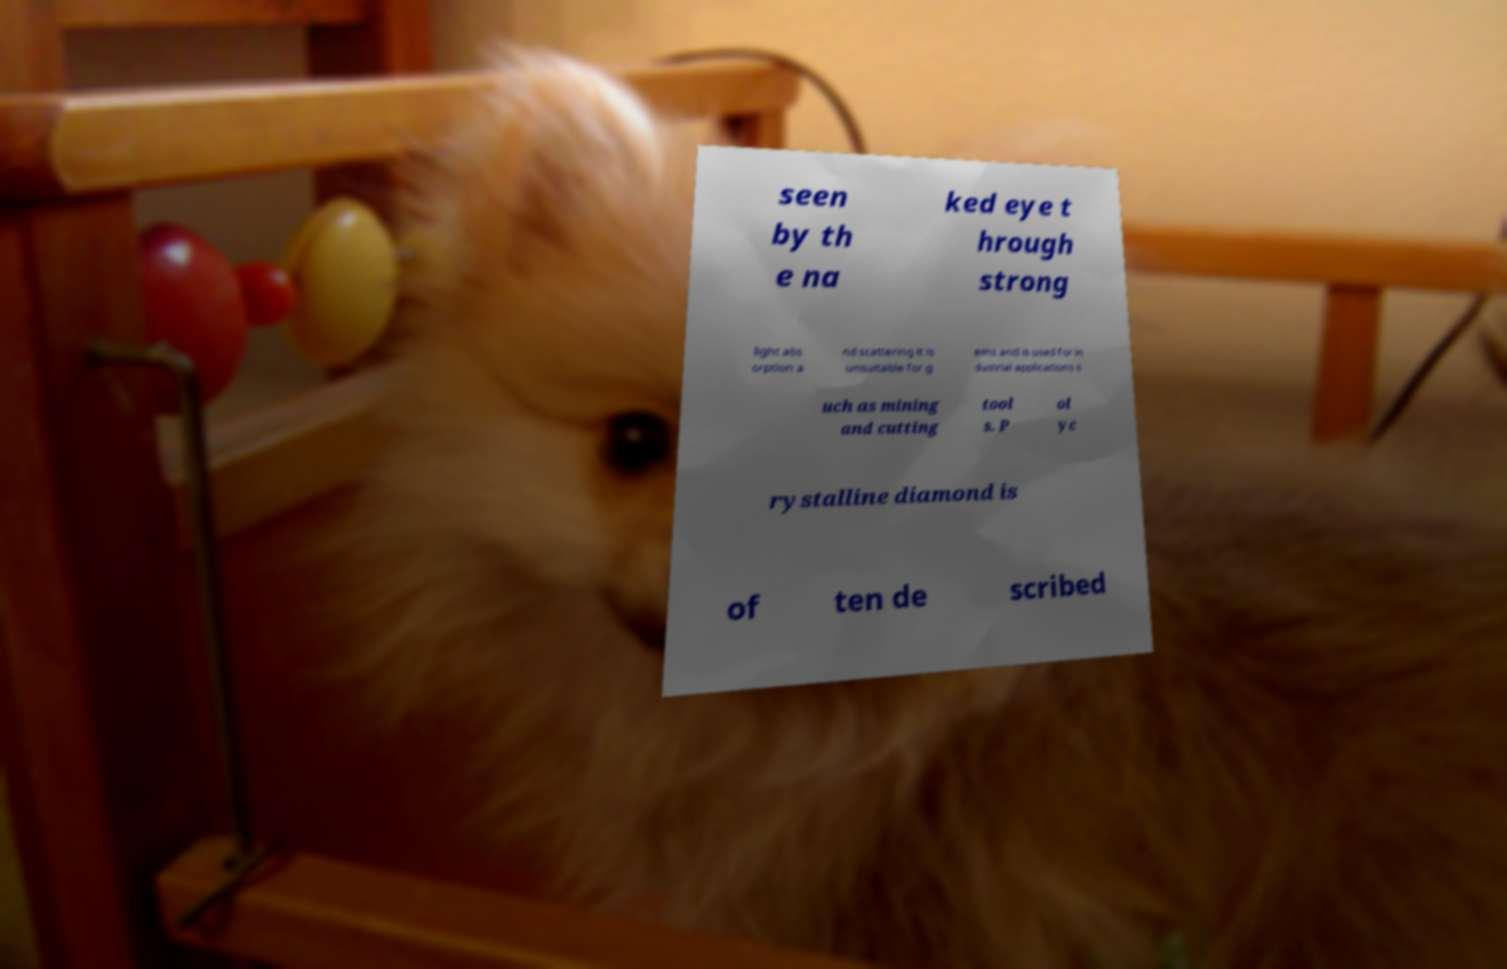Please identify and transcribe the text found in this image. seen by th e na ked eye t hrough strong light abs orption a nd scattering it is unsuitable for g ems and is used for in dustrial applications s uch as mining and cutting tool s. P ol yc rystalline diamond is of ten de scribed 